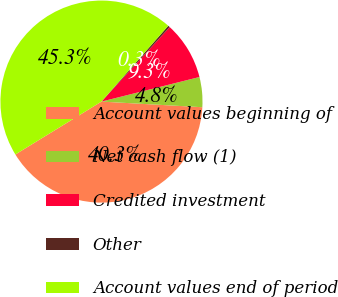<chart> <loc_0><loc_0><loc_500><loc_500><pie_chart><fcel>Account values beginning of<fcel>Net cash flow (1)<fcel>Credited investment<fcel>Other<fcel>Account values end of period<nl><fcel>40.34%<fcel>4.8%<fcel>9.29%<fcel>0.3%<fcel>45.26%<nl></chart> 